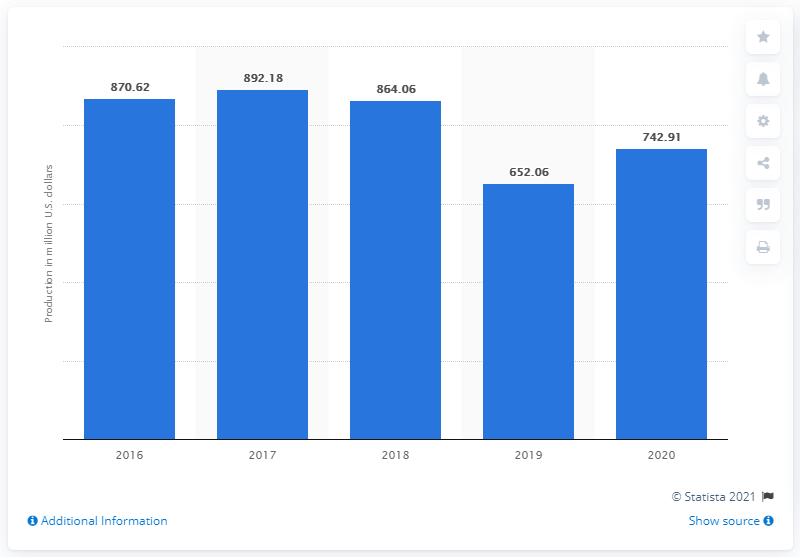Highlight a few significant elements in this photo. The production value of sweet corn for the fresh and processing market in the United States in 2020 was approximately $742.91. 